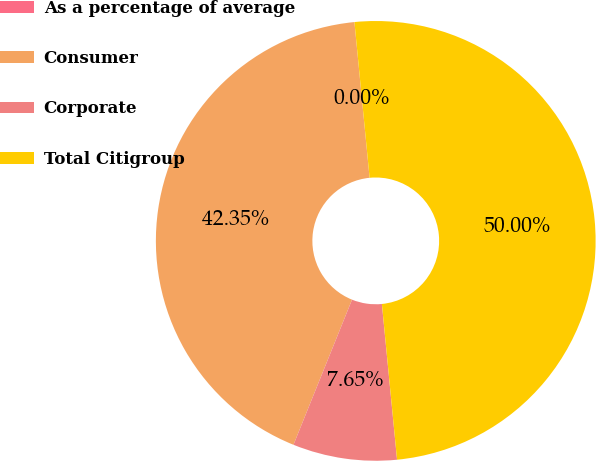Convert chart to OTSL. <chart><loc_0><loc_0><loc_500><loc_500><pie_chart><fcel>As a percentage of average<fcel>Consumer<fcel>Corporate<fcel>Total Citigroup<nl><fcel>0.0%<fcel>42.35%<fcel>7.65%<fcel>50.0%<nl></chart> 